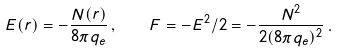<formula> <loc_0><loc_0><loc_500><loc_500>E ( r ) = - \frac { N ( r ) } { 8 \pi q _ { e } } \, , \quad F = - E ^ { 2 } / 2 = - \frac { N ^ { 2 } } { 2 ( 8 \pi q _ { e } ) ^ { 2 } } \, .</formula> 